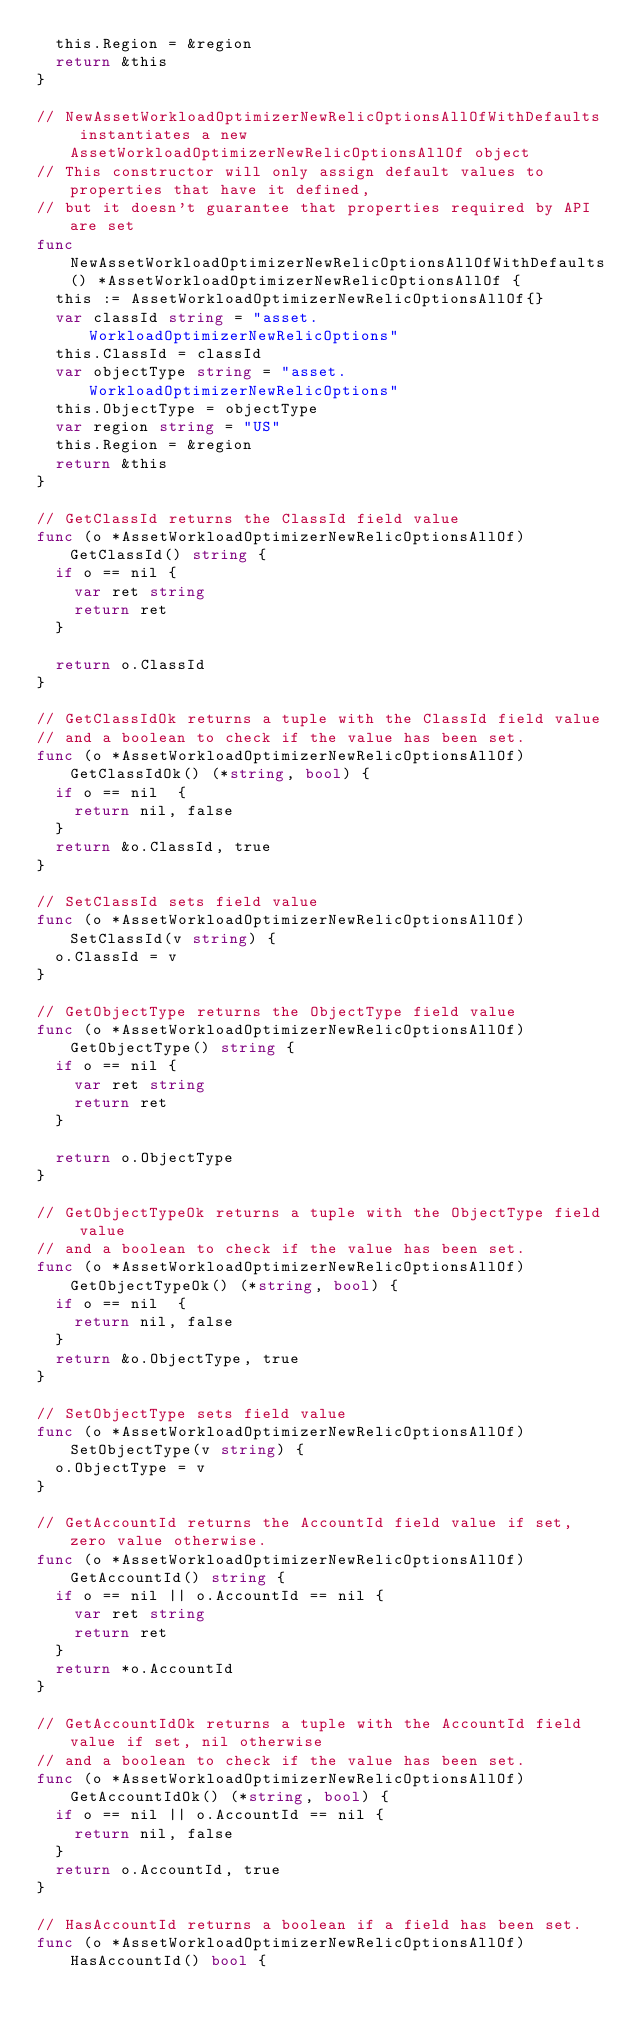Convert code to text. <code><loc_0><loc_0><loc_500><loc_500><_Go_>	this.Region = &region
	return &this
}

// NewAssetWorkloadOptimizerNewRelicOptionsAllOfWithDefaults instantiates a new AssetWorkloadOptimizerNewRelicOptionsAllOf object
// This constructor will only assign default values to properties that have it defined,
// but it doesn't guarantee that properties required by API are set
func NewAssetWorkloadOptimizerNewRelicOptionsAllOfWithDefaults() *AssetWorkloadOptimizerNewRelicOptionsAllOf {
	this := AssetWorkloadOptimizerNewRelicOptionsAllOf{}
	var classId string = "asset.WorkloadOptimizerNewRelicOptions"
	this.ClassId = classId
	var objectType string = "asset.WorkloadOptimizerNewRelicOptions"
	this.ObjectType = objectType
	var region string = "US"
	this.Region = &region
	return &this
}

// GetClassId returns the ClassId field value
func (o *AssetWorkloadOptimizerNewRelicOptionsAllOf) GetClassId() string {
	if o == nil {
		var ret string
		return ret
	}

	return o.ClassId
}

// GetClassIdOk returns a tuple with the ClassId field value
// and a boolean to check if the value has been set.
func (o *AssetWorkloadOptimizerNewRelicOptionsAllOf) GetClassIdOk() (*string, bool) {
	if o == nil  {
		return nil, false
	}
	return &o.ClassId, true
}

// SetClassId sets field value
func (o *AssetWorkloadOptimizerNewRelicOptionsAllOf) SetClassId(v string) {
	o.ClassId = v
}

// GetObjectType returns the ObjectType field value
func (o *AssetWorkloadOptimizerNewRelicOptionsAllOf) GetObjectType() string {
	if o == nil {
		var ret string
		return ret
	}

	return o.ObjectType
}

// GetObjectTypeOk returns a tuple with the ObjectType field value
// and a boolean to check if the value has been set.
func (o *AssetWorkloadOptimizerNewRelicOptionsAllOf) GetObjectTypeOk() (*string, bool) {
	if o == nil  {
		return nil, false
	}
	return &o.ObjectType, true
}

// SetObjectType sets field value
func (o *AssetWorkloadOptimizerNewRelicOptionsAllOf) SetObjectType(v string) {
	o.ObjectType = v
}

// GetAccountId returns the AccountId field value if set, zero value otherwise.
func (o *AssetWorkloadOptimizerNewRelicOptionsAllOf) GetAccountId() string {
	if o == nil || o.AccountId == nil {
		var ret string
		return ret
	}
	return *o.AccountId
}

// GetAccountIdOk returns a tuple with the AccountId field value if set, nil otherwise
// and a boolean to check if the value has been set.
func (o *AssetWorkloadOptimizerNewRelicOptionsAllOf) GetAccountIdOk() (*string, bool) {
	if o == nil || o.AccountId == nil {
		return nil, false
	}
	return o.AccountId, true
}

// HasAccountId returns a boolean if a field has been set.
func (o *AssetWorkloadOptimizerNewRelicOptionsAllOf) HasAccountId() bool {</code> 